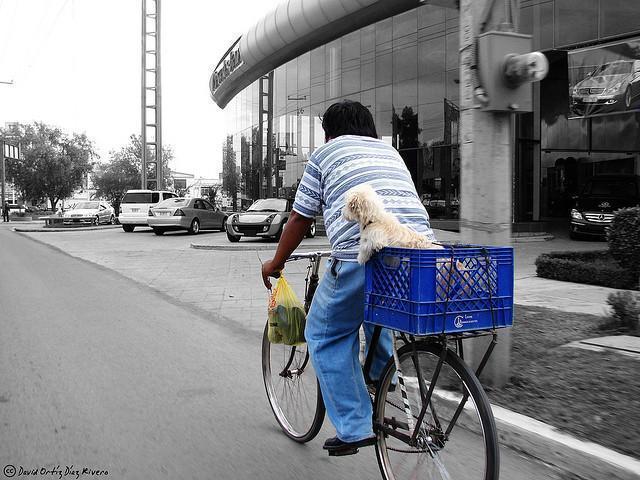Why is there a car poster on the building?
From the following set of four choices, select the accurate answer to respond to the question.
Options: Window cover, advertisement, decoration, missing poster. Advertisement. 